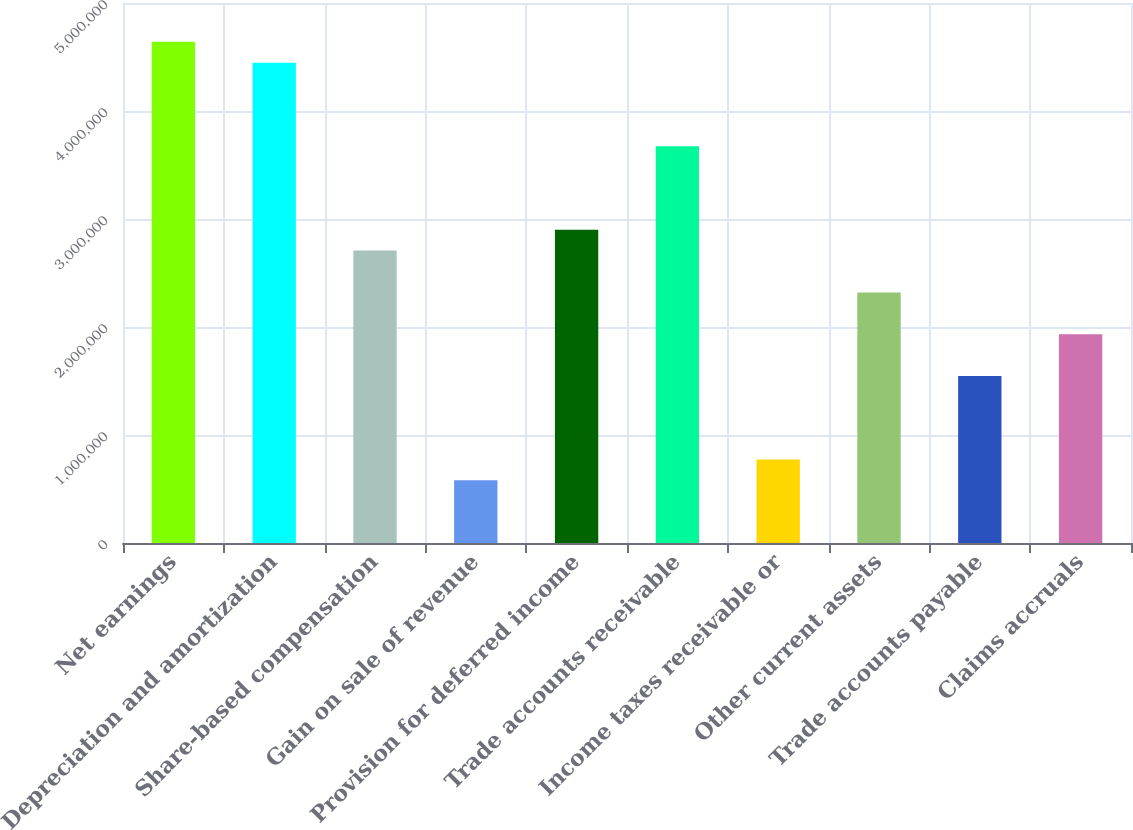Convert chart. <chart><loc_0><loc_0><loc_500><loc_500><bar_chart><fcel>Net earnings<fcel>Depreciation and amortization<fcel>Share-based compensation<fcel>Gain on sale of revenue<fcel>Provision for deferred income<fcel>Trade accounts receivable<fcel>Income taxes receivable or<fcel>Other current assets<fcel>Trade accounts payable<fcel>Claims accruals<nl><fcel>4.64096e+06<fcel>4.44758e+06<fcel>2.70724e+06<fcel>580152<fcel>2.90061e+06<fcel>3.6741e+06<fcel>773523<fcel>2.3205e+06<fcel>1.54701e+06<fcel>1.93375e+06<nl></chart> 